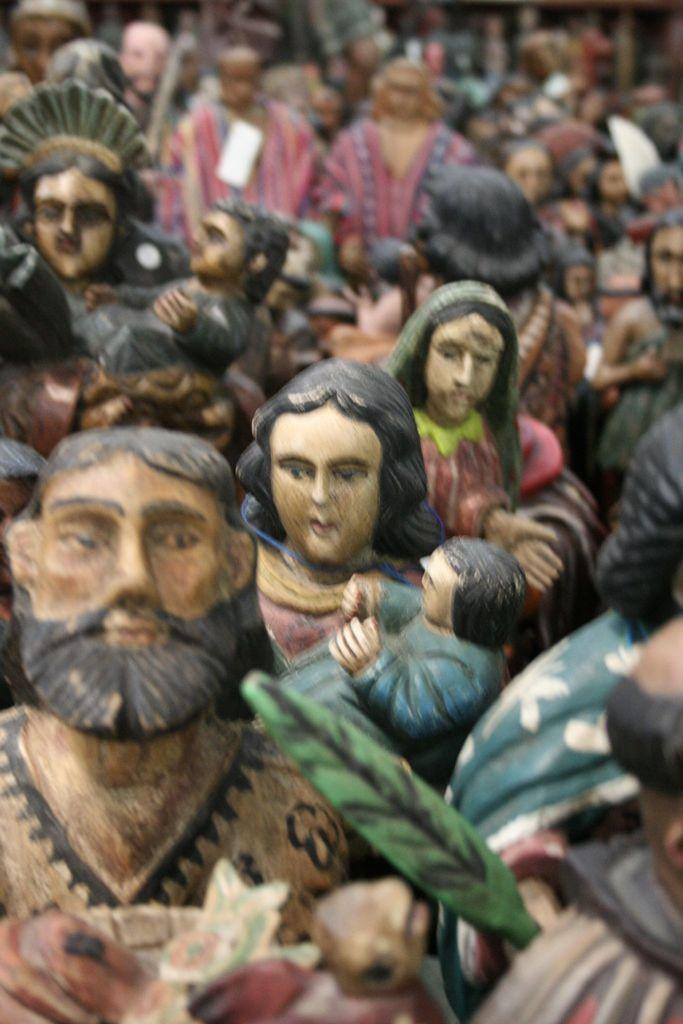What type of objects can be seen in the image? There are toys in the image. What type of substance is used to make the eggnog in the image? There is no eggnog present in the image; it only features toys. 